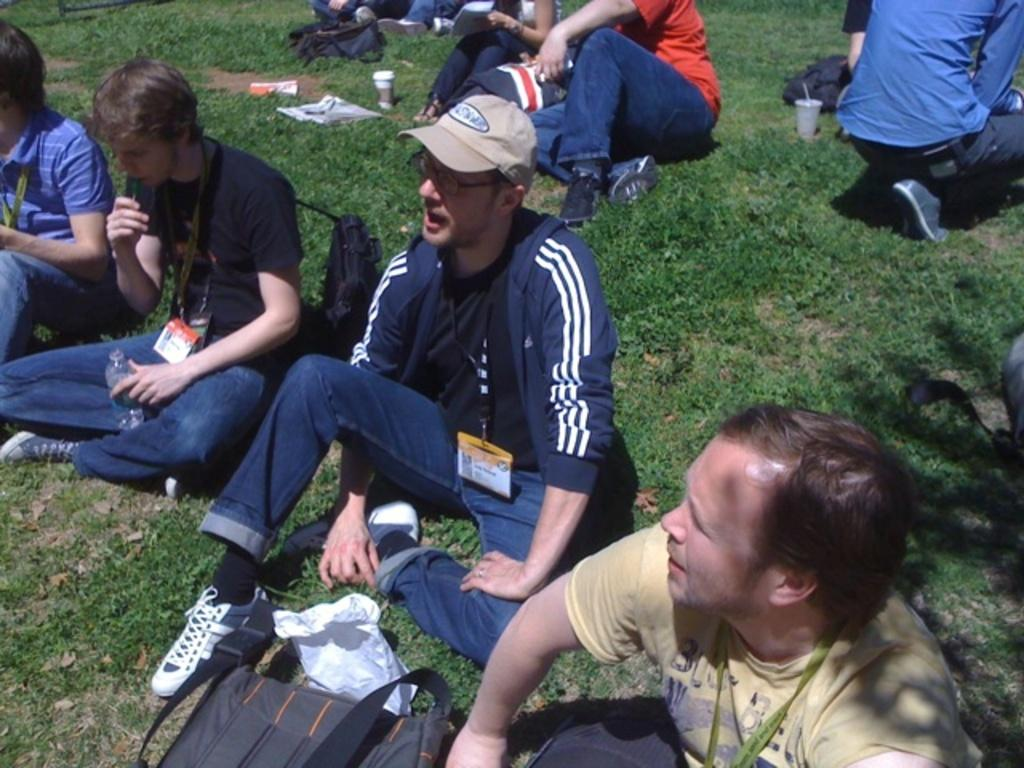What are the people in the image doing? The people in the image are sitting on the grass. Can you describe any objects visible in the image? There are a few objects visible in the image, but their specific details are not mentioned in the provided facts. What type of stamp can be seen on the volleyball in the image? There is no volleyball or stamp present in the image. 